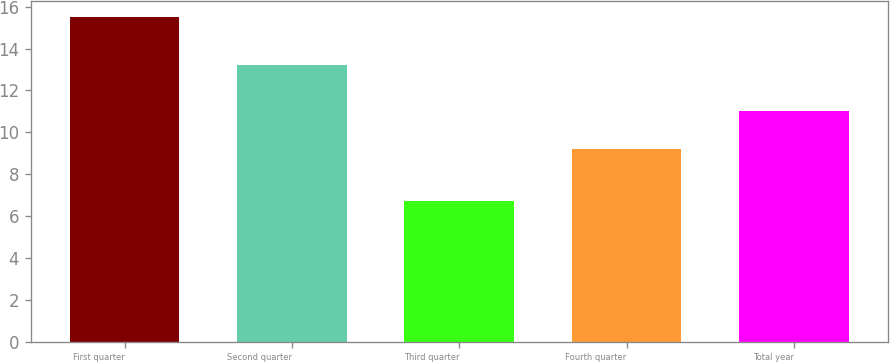Convert chart. <chart><loc_0><loc_0><loc_500><loc_500><bar_chart><fcel>First quarter<fcel>Second quarter<fcel>Third quarter<fcel>Fourth quarter<fcel>Total year<nl><fcel>15.5<fcel>13.2<fcel>6.7<fcel>9.2<fcel>11<nl></chart> 